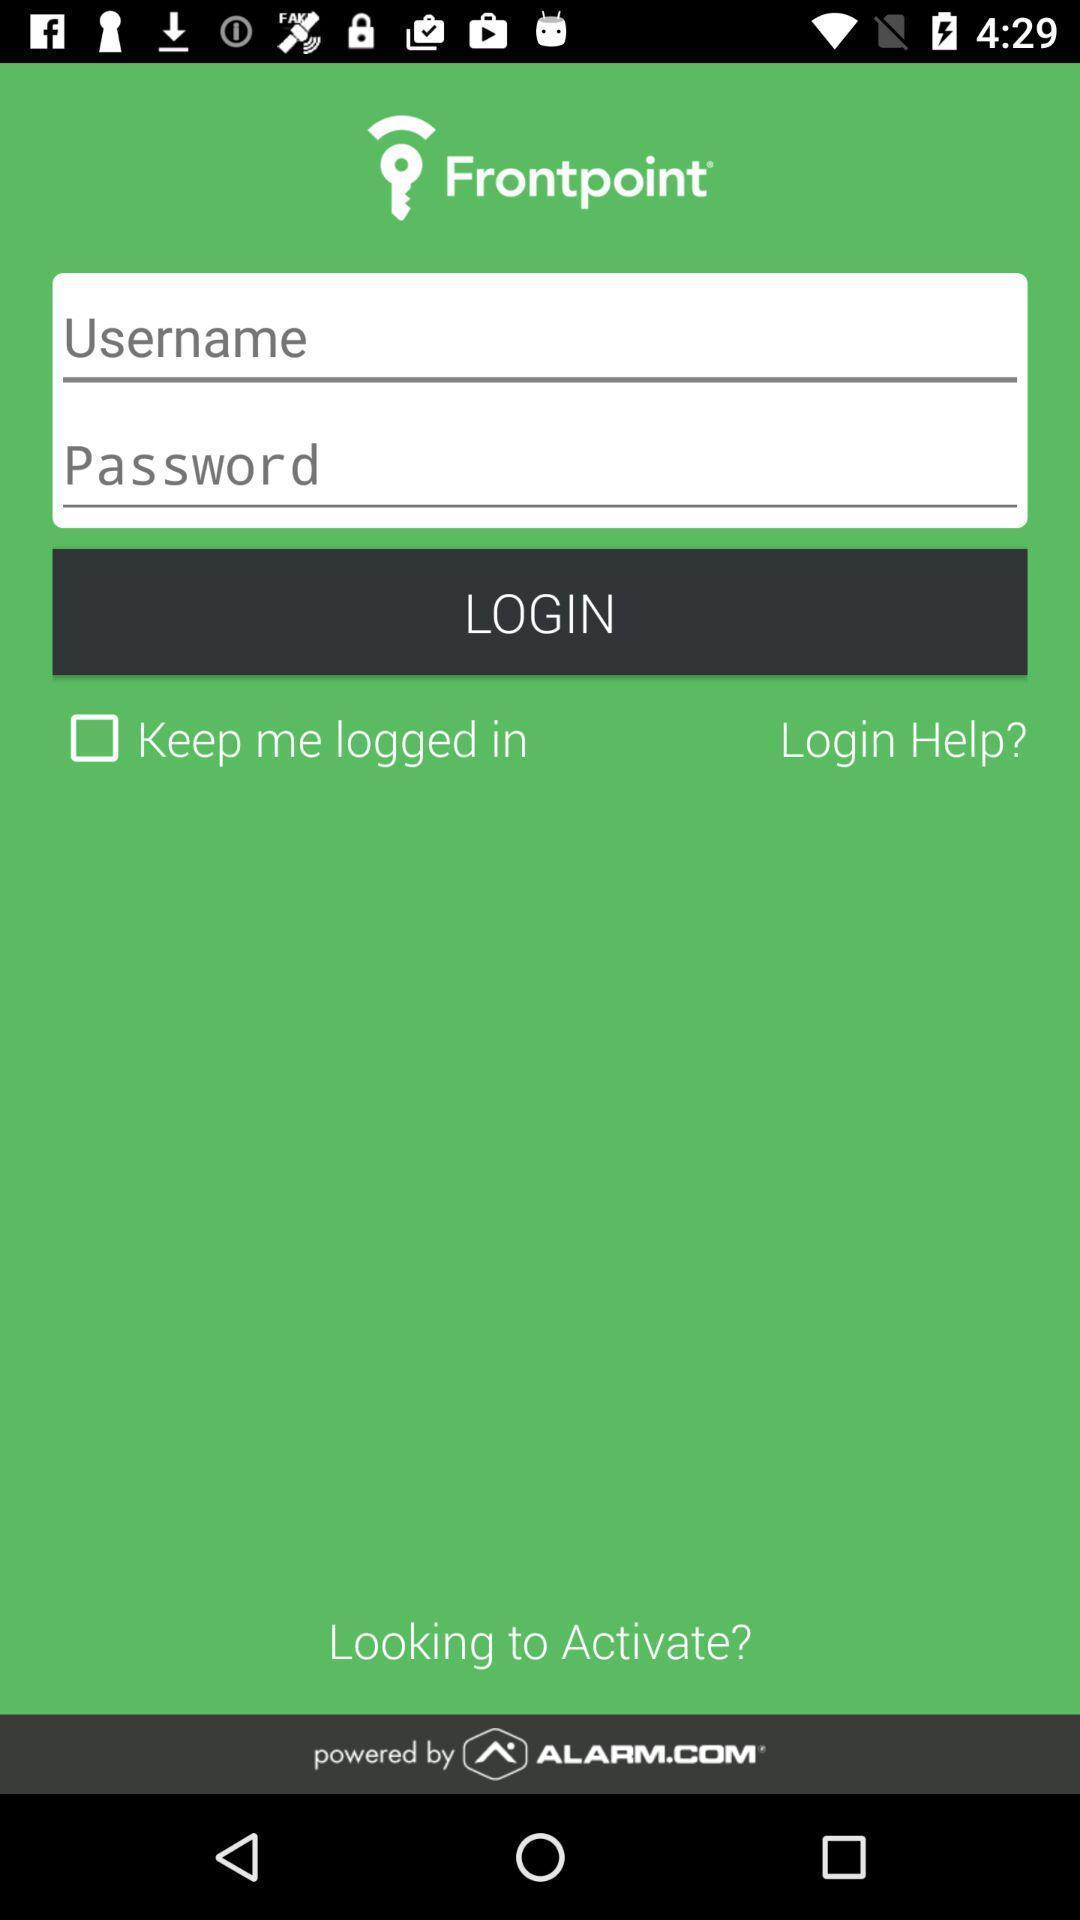Describe the content in this image. Screen displaying login page of a security application. 